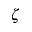Convert formula to latex. <formula><loc_0><loc_0><loc_500><loc_500>\zeta</formula> 